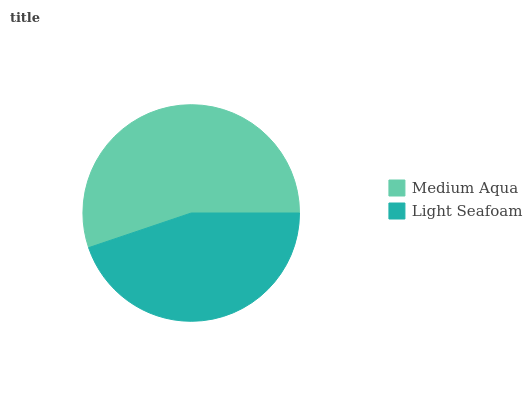Is Light Seafoam the minimum?
Answer yes or no. Yes. Is Medium Aqua the maximum?
Answer yes or no. Yes. Is Light Seafoam the maximum?
Answer yes or no. No. Is Medium Aqua greater than Light Seafoam?
Answer yes or no. Yes. Is Light Seafoam less than Medium Aqua?
Answer yes or no. Yes. Is Light Seafoam greater than Medium Aqua?
Answer yes or no. No. Is Medium Aqua less than Light Seafoam?
Answer yes or no. No. Is Medium Aqua the high median?
Answer yes or no. Yes. Is Light Seafoam the low median?
Answer yes or no. Yes. Is Light Seafoam the high median?
Answer yes or no. No. Is Medium Aqua the low median?
Answer yes or no. No. 